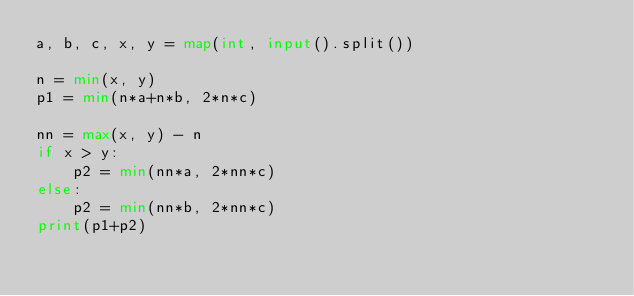<code> <loc_0><loc_0><loc_500><loc_500><_Python_>a, b, c, x, y = map(int, input().split())

n = min(x, y)
p1 = min(n*a+n*b, 2*n*c)

nn = max(x, y) - n
if x > y:
    p2 = min(nn*a, 2*nn*c)
else:
    p2 = min(nn*b, 2*nn*c)
print(p1+p2)
</code> 